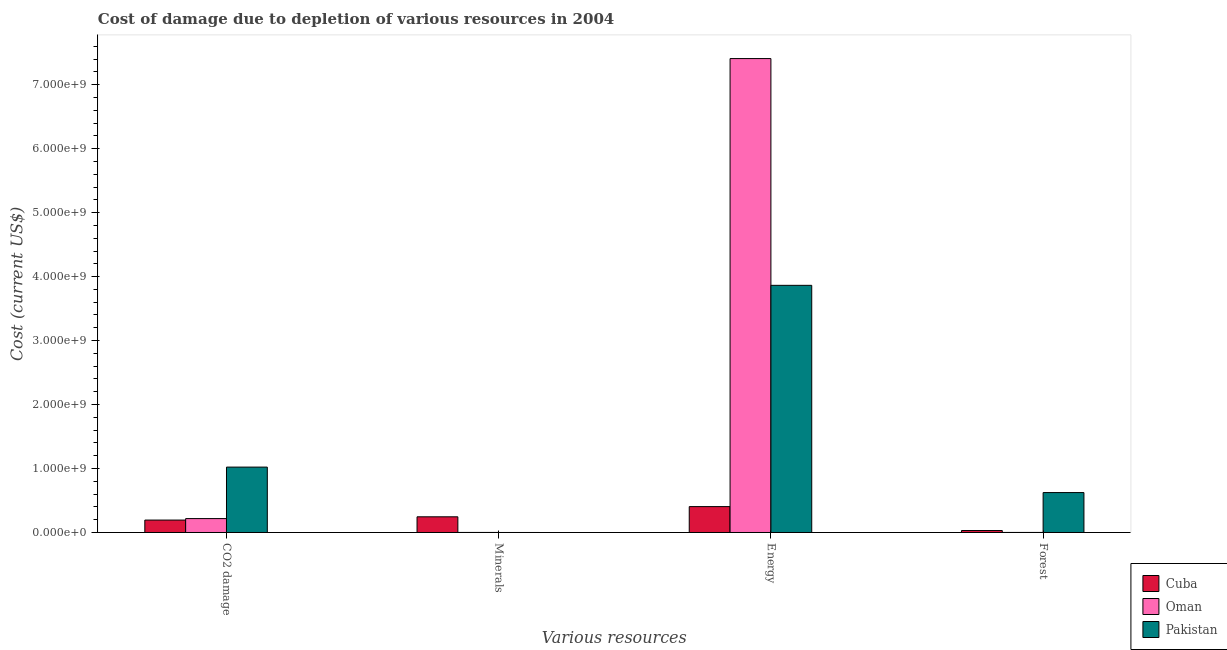How many different coloured bars are there?
Keep it short and to the point. 3. Are the number of bars per tick equal to the number of legend labels?
Give a very brief answer. Yes. How many bars are there on the 2nd tick from the right?
Offer a very short reply. 3. What is the label of the 3rd group of bars from the left?
Your response must be concise. Energy. What is the cost of damage due to depletion of minerals in Cuba?
Provide a succinct answer. 2.45e+08. Across all countries, what is the maximum cost of damage due to depletion of forests?
Your answer should be very brief. 6.24e+08. Across all countries, what is the minimum cost of damage due to depletion of minerals?
Offer a very short reply. 2.90e+04. In which country was the cost of damage due to depletion of coal maximum?
Your response must be concise. Pakistan. In which country was the cost of damage due to depletion of minerals minimum?
Make the answer very short. Pakistan. What is the total cost of damage due to depletion of energy in the graph?
Keep it short and to the point. 1.17e+1. What is the difference between the cost of damage due to depletion of coal in Oman and that in Pakistan?
Offer a very short reply. -8.05e+08. What is the difference between the cost of damage due to depletion of energy in Pakistan and the cost of damage due to depletion of minerals in Cuba?
Your response must be concise. 3.62e+09. What is the average cost of damage due to depletion of coal per country?
Provide a short and direct response. 4.78e+08. What is the difference between the cost of damage due to depletion of forests and cost of damage due to depletion of energy in Oman?
Keep it short and to the point. -7.41e+09. What is the ratio of the cost of damage due to depletion of forests in Pakistan to that in Oman?
Provide a short and direct response. 890.96. Is the cost of damage due to depletion of energy in Pakistan less than that in Cuba?
Your answer should be compact. No. What is the difference between the highest and the second highest cost of damage due to depletion of minerals?
Give a very brief answer. 2.45e+08. What is the difference between the highest and the lowest cost of damage due to depletion of forests?
Make the answer very short. 6.23e+08. Is the sum of the cost of damage due to depletion of forests in Oman and Cuba greater than the maximum cost of damage due to depletion of energy across all countries?
Provide a short and direct response. No. What does the 3rd bar from the right in Energy represents?
Make the answer very short. Cuba. Is it the case that in every country, the sum of the cost of damage due to depletion of coal and cost of damage due to depletion of minerals is greater than the cost of damage due to depletion of energy?
Your answer should be very brief. No. How many countries are there in the graph?
Ensure brevity in your answer.  3. What is the difference between two consecutive major ticks on the Y-axis?
Give a very brief answer. 1.00e+09. Does the graph contain any zero values?
Give a very brief answer. No. Does the graph contain grids?
Ensure brevity in your answer.  No. How are the legend labels stacked?
Provide a succinct answer. Vertical. What is the title of the graph?
Provide a short and direct response. Cost of damage due to depletion of various resources in 2004 . What is the label or title of the X-axis?
Provide a short and direct response. Various resources. What is the label or title of the Y-axis?
Give a very brief answer. Cost (current US$). What is the Cost (current US$) in Cuba in CO2 damage?
Make the answer very short. 1.94e+08. What is the Cost (current US$) in Oman in CO2 damage?
Give a very brief answer. 2.17e+08. What is the Cost (current US$) of Pakistan in CO2 damage?
Give a very brief answer. 1.02e+09. What is the Cost (current US$) of Cuba in Minerals?
Keep it short and to the point. 2.45e+08. What is the Cost (current US$) of Oman in Minerals?
Make the answer very short. 5.32e+05. What is the Cost (current US$) of Pakistan in Minerals?
Offer a very short reply. 2.90e+04. What is the Cost (current US$) of Cuba in Energy?
Ensure brevity in your answer.  4.05e+08. What is the Cost (current US$) of Oman in Energy?
Offer a very short reply. 7.41e+09. What is the Cost (current US$) in Pakistan in Energy?
Offer a very short reply. 3.86e+09. What is the Cost (current US$) of Cuba in Forest?
Provide a short and direct response. 3.08e+07. What is the Cost (current US$) of Oman in Forest?
Provide a short and direct response. 7.00e+05. What is the Cost (current US$) in Pakistan in Forest?
Your answer should be compact. 6.24e+08. Across all Various resources, what is the maximum Cost (current US$) in Cuba?
Your answer should be very brief. 4.05e+08. Across all Various resources, what is the maximum Cost (current US$) in Oman?
Your answer should be very brief. 7.41e+09. Across all Various resources, what is the maximum Cost (current US$) in Pakistan?
Provide a short and direct response. 3.86e+09. Across all Various resources, what is the minimum Cost (current US$) of Cuba?
Your answer should be compact. 3.08e+07. Across all Various resources, what is the minimum Cost (current US$) in Oman?
Your answer should be compact. 5.32e+05. Across all Various resources, what is the minimum Cost (current US$) in Pakistan?
Offer a very short reply. 2.90e+04. What is the total Cost (current US$) of Cuba in the graph?
Offer a terse response. 8.75e+08. What is the total Cost (current US$) in Oman in the graph?
Your answer should be compact. 7.63e+09. What is the total Cost (current US$) in Pakistan in the graph?
Make the answer very short. 5.51e+09. What is the difference between the Cost (current US$) of Cuba in CO2 damage and that in Minerals?
Your response must be concise. -5.10e+07. What is the difference between the Cost (current US$) of Oman in CO2 damage and that in Minerals?
Provide a short and direct response. 2.17e+08. What is the difference between the Cost (current US$) in Pakistan in CO2 damage and that in Minerals?
Your answer should be compact. 1.02e+09. What is the difference between the Cost (current US$) in Cuba in CO2 damage and that in Energy?
Keep it short and to the point. -2.10e+08. What is the difference between the Cost (current US$) of Oman in CO2 damage and that in Energy?
Provide a succinct answer. -7.19e+09. What is the difference between the Cost (current US$) in Pakistan in CO2 damage and that in Energy?
Ensure brevity in your answer.  -2.84e+09. What is the difference between the Cost (current US$) of Cuba in CO2 damage and that in Forest?
Provide a succinct answer. 1.63e+08. What is the difference between the Cost (current US$) in Oman in CO2 damage and that in Forest?
Keep it short and to the point. 2.17e+08. What is the difference between the Cost (current US$) of Pakistan in CO2 damage and that in Forest?
Your answer should be very brief. 3.98e+08. What is the difference between the Cost (current US$) of Cuba in Minerals and that in Energy?
Provide a short and direct response. -1.59e+08. What is the difference between the Cost (current US$) of Oman in Minerals and that in Energy?
Provide a short and direct response. -7.41e+09. What is the difference between the Cost (current US$) of Pakistan in Minerals and that in Energy?
Your answer should be compact. -3.86e+09. What is the difference between the Cost (current US$) in Cuba in Minerals and that in Forest?
Your answer should be compact. 2.14e+08. What is the difference between the Cost (current US$) of Oman in Minerals and that in Forest?
Make the answer very short. -1.69e+05. What is the difference between the Cost (current US$) of Pakistan in Minerals and that in Forest?
Give a very brief answer. -6.24e+08. What is the difference between the Cost (current US$) of Cuba in Energy and that in Forest?
Provide a succinct answer. 3.74e+08. What is the difference between the Cost (current US$) in Oman in Energy and that in Forest?
Offer a very short reply. 7.41e+09. What is the difference between the Cost (current US$) of Pakistan in Energy and that in Forest?
Offer a very short reply. 3.24e+09. What is the difference between the Cost (current US$) in Cuba in CO2 damage and the Cost (current US$) in Oman in Minerals?
Offer a terse response. 1.94e+08. What is the difference between the Cost (current US$) of Cuba in CO2 damage and the Cost (current US$) of Pakistan in Minerals?
Offer a very short reply. 1.94e+08. What is the difference between the Cost (current US$) of Oman in CO2 damage and the Cost (current US$) of Pakistan in Minerals?
Your answer should be very brief. 2.17e+08. What is the difference between the Cost (current US$) of Cuba in CO2 damage and the Cost (current US$) of Oman in Energy?
Your answer should be compact. -7.21e+09. What is the difference between the Cost (current US$) of Cuba in CO2 damage and the Cost (current US$) of Pakistan in Energy?
Your response must be concise. -3.67e+09. What is the difference between the Cost (current US$) in Oman in CO2 damage and the Cost (current US$) in Pakistan in Energy?
Make the answer very short. -3.65e+09. What is the difference between the Cost (current US$) in Cuba in CO2 damage and the Cost (current US$) in Oman in Forest?
Offer a terse response. 1.94e+08. What is the difference between the Cost (current US$) of Cuba in CO2 damage and the Cost (current US$) of Pakistan in Forest?
Offer a terse response. -4.30e+08. What is the difference between the Cost (current US$) of Oman in CO2 damage and the Cost (current US$) of Pakistan in Forest?
Offer a very short reply. -4.07e+08. What is the difference between the Cost (current US$) in Cuba in Minerals and the Cost (current US$) in Oman in Energy?
Your answer should be very brief. -7.16e+09. What is the difference between the Cost (current US$) in Cuba in Minerals and the Cost (current US$) in Pakistan in Energy?
Keep it short and to the point. -3.62e+09. What is the difference between the Cost (current US$) in Oman in Minerals and the Cost (current US$) in Pakistan in Energy?
Offer a terse response. -3.86e+09. What is the difference between the Cost (current US$) of Cuba in Minerals and the Cost (current US$) of Oman in Forest?
Give a very brief answer. 2.45e+08. What is the difference between the Cost (current US$) in Cuba in Minerals and the Cost (current US$) in Pakistan in Forest?
Give a very brief answer. -3.79e+08. What is the difference between the Cost (current US$) in Oman in Minerals and the Cost (current US$) in Pakistan in Forest?
Provide a short and direct response. -6.23e+08. What is the difference between the Cost (current US$) in Cuba in Energy and the Cost (current US$) in Oman in Forest?
Offer a very short reply. 4.04e+08. What is the difference between the Cost (current US$) of Cuba in Energy and the Cost (current US$) of Pakistan in Forest?
Provide a succinct answer. -2.19e+08. What is the difference between the Cost (current US$) in Oman in Energy and the Cost (current US$) in Pakistan in Forest?
Your answer should be very brief. 6.78e+09. What is the average Cost (current US$) of Cuba per Various resources?
Ensure brevity in your answer.  2.19e+08. What is the average Cost (current US$) in Oman per Various resources?
Your answer should be compact. 1.91e+09. What is the average Cost (current US$) in Pakistan per Various resources?
Provide a succinct answer. 1.38e+09. What is the difference between the Cost (current US$) of Cuba and Cost (current US$) of Oman in CO2 damage?
Offer a very short reply. -2.32e+07. What is the difference between the Cost (current US$) of Cuba and Cost (current US$) of Pakistan in CO2 damage?
Provide a short and direct response. -8.28e+08. What is the difference between the Cost (current US$) of Oman and Cost (current US$) of Pakistan in CO2 damage?
Keep it short and to the point. -8.05e+08. What is the difference between the Cost (current US$) of Cuba and Cost (current US$) of Oman in Minerals?
Your answer should be very brief. 2.45e+08. What is the difference between the Cost (current US$) of Cuba and Cost (current US$) of Pakistan in Minerals?
Make the answer very short. 2.45e+08. What is the difference between the Cost (current US$) in Oman and Cost (current US$) in Pakistan in Minerals?
Keep it short and to the point. 5.03e+05. What is the difference between the Cost (current US$) of Cuba and Cost (current US$) of Oman in Energy?
Give a very brief answer. -7.00e+09. What is the difference between the Cost (current US$) of Cuba and Cost (current US$) of Pakistan in Energy?
Offer a terse response. -3.46e+09. What is the difference between the Cost (current US$) in Oman and Cost (current US$) in Pakistan in Energy?
Offer a very short reply. 3.54e+09. What is the difference between the Cost (current US$) of Cuba and Cost (current US$) of Oman in Forest?
Give a very brief answer. 3.01e+07. What is the difference between the Cost (current US$) in Cuba and Cost (current US$) in Pakistan in Forest?
Offer a terse response. -5.93e+08. What is the difference between the Cost (current US$) of Oman and Cost (current US$) of Pakistan in Forest?
Provide a short and direct response. -6.23e+08. What is the ratio of the Cost (current US$) of Cuba in CO2 damage to that in Minerals?
Your response must be concise. 0.79. What is the ratio of the Cost (current US$) of Oman in CO2 damage to that in Minerals?
Your response must be concise. 408.82. What is the ratio of the Cost (current US$) in Pakistan in CO2 damage to that in Minerals?
Offer a very short reply. 3.53e+04. What is the ratio of the Cost (current US$) in Cuba in CO2 damage to that in Energy?
Make the answer very short. 0.48. What is the ratio of the Cost (current US$) of Oman in CO2 damage to that in Energy?
Make the answer very short. 0.03. What is the ratio of the Cost (current US$) of Pakistan in CO2 damage to that in Energy?
Offer a terse response. 0.26. What is the ratio of the Cost (current US$) in Cuba in CO2 damage to that in Forest?
Offer a terse response. 6.32. What is the ratio of the Cost (current US$) of Oman in CO2 damage to that in Forest?
Give a very brief answer. 310.41. What is the ratio of the Cost (current US$) of Pakistan in CO2 damage to that in Forest?
Offer a very short reply. 1.64. What is the ratio of the Cost (current US$) of Cuba in Minerals to that in Energy?
Your answer should be very brief. 0.61. What is the ratio of the Cost (current US$) in Pakistan in Minerals to that in Energy?
Provide a short and direct response. 0. What is the ratio of the Cost (current US$) of Cuba in Minerals to that in Forest?
Your answer should be compact. 7.97. What is the ratio of the Cost (current US$) in Oman in Minerals to that in Forest?
Provide a short and direct response. 0.76. What is the ratio of the Cost (current US$) in Cuba in Energy to that in Forest?
Provide a succinct answer. 13.16. What is the ratio of the Cost (current US$) in Oman in Energy to that in Forest?
Ensure brevity in your answer.  1.06e+04. What is the ratio of the Cost (current US$) in Pakistan in Energy to that in Forest?
Offer a very short reply. 6.19. What is the difference between the highest and the second highest Cost (current US$) in Cuba?
Your answer should be very brief. 1.59e+08. What is the difference between the highest and the second highest Cost (current US$) of Oman?
Give a very brief answer. 7.19e+09. What is the difference between the highest and the second highest Cost (current US$) in Pakistan?
Ensure brevity in your answer.  2.84e+09. What is the difference between the highest and the lowest Cost (current US$) in Cuba?
Provide a succinct answer. 3.74e+08. What is the difference between the highest and the lowest Cost (current US$) of Oman?
Make the answer very short. 7.41e+09. What is the difference between the highest and the lowest Cost (current US$) in Pakistan?
Ensure brevity in your answer.  3.86e+09. 